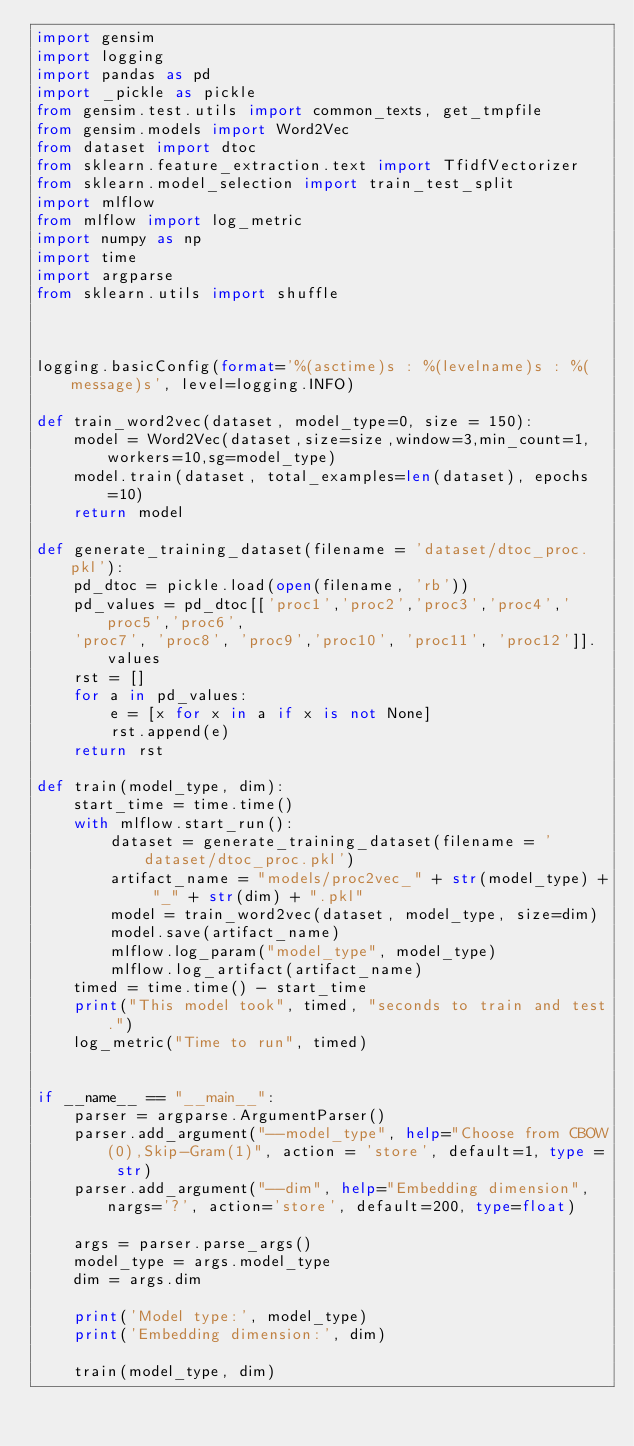<code> <loc_0><loc_0><loc_500><loc_500><_Python_>import gensim 
import logging
import pandas as pd
import _pickle as pickle
from gensim.test.utils import common_texts, get_tmpfile
from gensim.models import Word2Vec
from dataset import dtoc
from sklearn.feature_extraction.text import TfidfVectorizer
from sklearn.model_selection import train_test_split
import mlflow
from mlflow import log_metric
import numpy as np
import time 
import argparse
from sklearn.utils import shuffle



logging.basicConfig(format='%(asctime)s : %(levelname)s : %(message)s', level=logging.INFO)
 
def train_word2vec(dataset, model_type=0, size = 150):
    model = Word2Vec(dataset,size=size,window=3,min_count=1,workers=10,sg=model_type)
    model.train(dataset, total_examples=len(dataset), epochs=10)
    return model

def generate_training_dataset(filename = 'dataset/dtoc_proc.pkl'): 
    pd_dtoc = pickle.load(open(filename, 'rb'))
    pd_values = pd_dtoc[['proc1','proc2','proc3','proc4','proc5','proc6', 
    'proc7', 'proc8', 'proc9','proc10', 'proc11', 'proc12']].values
    rst = []
    for a in pd_values:
        e = [x for x in a if x is not None]
        rst.append(e)
    return rst

def train(model_type, dim):
    start_time = time.time()
    with mlflow.start_run():
        dataset = generate_training_dataset(filename = 'dataset/dtoc_proc.pkl')
        artifact_name = "models/proc2vec_" + str(model_type) + "_" + str(dim) + ".pkl"
        model = train_word2vec(dataset, model_type, size=dim)
        model.save(artifact_name)
        mlflow.log_param("model_type", model_type)
        mlflow.log_artifact(artifact_name)
    timed = time.time() - start_time
    print("This model took", timed, "seconds to train and test.")
    log_metric("Time to run", timed)


if __name__ == "__main__":
    parser = argparse.ArgumentParser()
    parser.add_argument("--model_type", help="Choose from CBOW(0),Skip-Gram(1)", action = 'store', default=1, type = str)
    parser.add_argument("--dim", help="Embedding dimension", nargs='?', action='store', default=200, type=float)
    
    args = parser.parse_args()
    model_type = args.model_type
    dim = args.dim

    print('Model type:', model_type)
    print('Embedding dimension:', dim)
    
    train(model_type, dim)</code> 